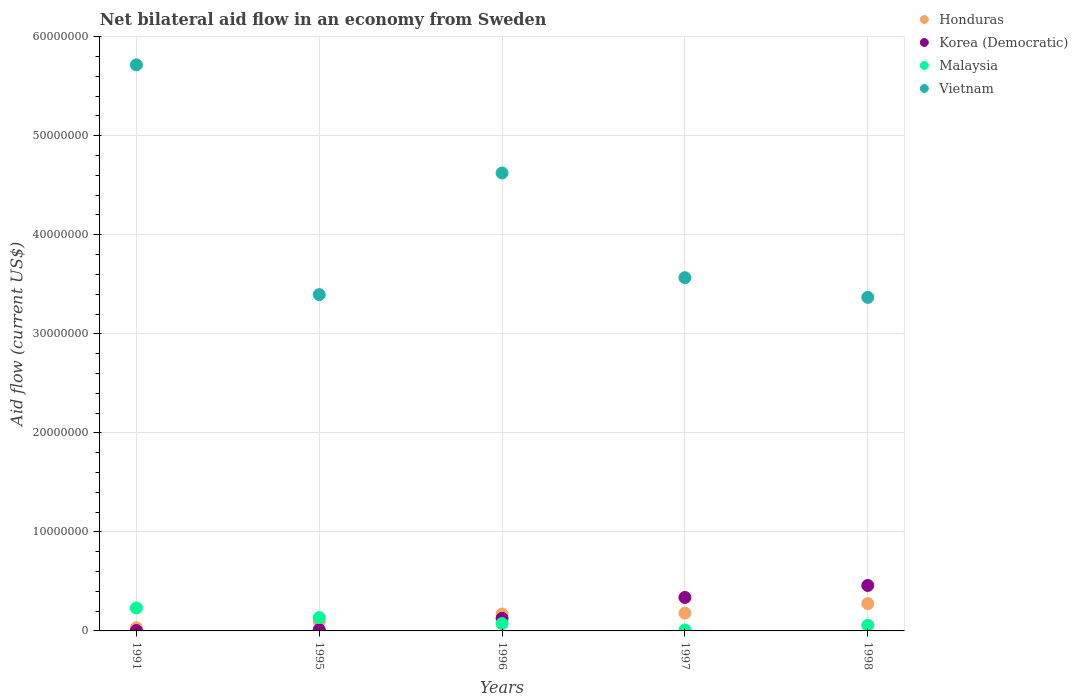What is the net bilateral aid flow in Malaysia in 1991?
Your response must be concise. 2.32e+06. Across all years, what is the maximum net bilateral aid flow in Korea (Democratic)?
Your answer should be compact. 4.59e+06. In which year was the net bilateral aid flow in Malaysia maximum?
Offer a terse response. 1991. In which year was the net bilateral aid flow in Malaysia minimum?
Provide a short and direct response. 1997. What is the total net bilateral aid flow in Korea (Democratic) in the graph?
Your response must be concise. 9.41e+06. What is the difference between the net bilateral aid flow in Korea (Democratic) in 1991 and that in 1997?
Keep it short and to the point. -3.34e+06. What is the difference between the net bilateral aid flow in Honduras in 1998 and the net bilateral aid flow in Malaysia in 1997?
Your answer should be very brief. 2.66e+06. What is the average net bilateral aid flow in Malaysia per year?
Make the answer very short. 1.02e+06. In the year 1997, what is the difference between the net bilateral aid flow in Korea (Democratic) and net bilateral aid flow in Malaysia?
Ensure brevity in your answer.  3.28e+06. In how many years, is the net bilateral aid flow in Honduras greater than 20000000 US$?
Provide a short and direct response. 0. What is the ratio of the net bilateral aid flow in Vietnam in 1991 to that in 1997?
Give a very brief answer. 1.6. Is the net bilateral aid flow in Vietnam in 1997 less than that in 1998?
Offer a very short reply. No. Is the difference between the net bilateral aid flow in Korea (Democratic) in 1991 and 1997 greater than the difference between the net bilateral aid flow in Malaysia in 1991 and 1997?
Provide a succinct answer. No. What is the difference between the highest and the second highest net bilateral aid flow in Vietnam?
Your response must be concise. 1.09e+07. What is the difference between the highest and the lowest net bilateral aid flow in Malaysia?
Your answer should be compact. 2.22e+06. In how many years, is the net bilateral aid flow in Vietnam greater than the average net bilateral aid flow in Vietnam taken over all years?
Keep it short and to the point. 2. Is the sum of the net bilateral aid flow in Honduras in 1995 and 1997 greater than the maximum net bilateral aid flow in Korea (Democratic) across all years?
Offer a very short reply. No. Is it the case that in every year, the sum of the net bilateral aid flow in Honduras and net bilateral aid flow in Korea (Democratic)  is greater than the sum of net bilateral aid flow in Malaysia and net bilateral aid flow in Vietnam?
Give a very brief answer. No. Is the net bilateral aid flow in Vietnam strictly greater than the net bilateral aid flow in Honduras over the years?
Give a very brief answer. Yes. How many years are there in the graph?
Your answer should be very brief. 5. Does the graph contain any zero values?
Keep it short and to the point. No. Where does the legend appear in the graph?
Your answer should be very brief. Top right. How many legend labels are there?
Offer a very short reply. 4. What is the title of the graph?
Give a very brief answer. Net bilateral aid flow in an economy from Sweden. What is the label or title of the Y-axis?
Your answer should be compact. Aid flow (current US$). What is the Aid flow (current US$) of Malaysia in 1991?
Provide a succinct answer. 2.32e+06. What is the Aid flow (current US$) in Vietnam in 1991?
Ensure brevity in your answer.  5.72e+07. What is the Aid flow (current US$) in Honduras in 1995?
Provide a short and direct response. 9.50e+05. What is the Aid flow (current US$) in Korea (Democratic) in 1995?
Provide a short and direct response. 1.30e+05. What is the Aid flow (current US$) of Malaysia in 1995?
Offer a very short reply. 1.35e+06. What is the Aid flow (current US$) of Vietnam in 1995?
Give a very brief answer. 3.40e+07. What is the Aid flow (current US$) of Honduras in 1996?
Your answer should be very brief. 1.71e+06. What is the Aid flow (current US$) of Korea (Democratic) in 1996?
Ensure brevity in your answer.  1.27e+06. What is the Aid flow (current US$) in Malaysia in 1996?
Offer a very short reply. 7.40e+05. What is the Aid flow (current US$) of Vietnam in 1996?
Provide a short and direct response. 4.62e+07. What is the Aid flow (current US$) in Honduras in 1997?
Offer a very short reply. 1.80e+06. What is the Aid flow (current US$) of Korea (Democratic) in 1997?
Provide a short and direct response. 3.38e+06. What is the Aid flow (current US$) of Vietnam in 1997?
Give a very brief answer. 3.57e+07. What is the Aid flow (current US$) in Honduras in 1998?
Give a very brief answer. 2.76e+06. What is the Aid flow (current US$) of Korea (Democratic) in 1998?
Make the answer very short. 4.59e+06. What is the Aid flow (current US$) in Malaysia in 1998?
Offer a terse response. 5.70e+05. What is the Aid flow (current US$) in Vietnam in 1998?
Offer a very short reply. 3.37e+07. Across all years, what is the maximum Aid flow (current US$) in Honduras?
Provide a succinct answer. 2.76e+06. Across all years, what is the maximum Aid flow (current US$) in Korea (Democratic)?
Provide a short and direct response. 4.59e+06. Across all years, what is the maximum Aid flow (current US$) of Malaysia?
Offer a very short reply. 2.32e+06. Across all years, what is the maximum Aid flow (current US$) of Vietnam?
Give a very brief answer. 5.72e+07. Across all years, what is the minimum Aid flow (current US$) in Vietnam?
Offer a terse response. 3.37e+07. What is the total Aid flow (current US$) of Honduras in the graph?
Offer a terse response. 7.53e+06. What is the total Aid flow (current US$) of Korea (Democratic) in the graph?
Provide a succinct answer. 9.41e+06. What is the total Aid flow (current US$) in Malaysia in the graph?
Make the answer very short. 5.08e+06. What is the total Aid flow (current US$) of Vietnam in the graph?
Make the answer very short. 2.07e+08. What is the difference between the Aid flow (current US$) of Honduras in 1991 and that in 1995?
Provide a succinct answer. -6.40e+05. What is the difference between the Aid flow (current US$) of Korea (Democratic) in 1991 and that in 1995?
Keep it short and to the point. -9.00e+04. What is the difference between the Aid flow (current US$) in Malaysia in 1991 and that in 1995?
Your answer should be very brief. 9.70e+05. What is the difference between the Aid flow (current US$) in Vietnam in 1991 and that in 1995?
Your answer should be very brief. 2.32e+07. What is the difference between the Aid flow (current US$) in Honduras in 1991 and that in 1996?
Offer a very short reply. -1.40e+06. What is the difference between the Aid flow (current US$) in Korea (Democratic) in 1991 and that in 1996?
Your answer should be very brief. -1.23e+06. What is the difference between the Aid flow (current US$) in Malaysia in 1991 and that in 1996?
Keep it short and to the point. 1.58e+06. What is the difference between the Aid flow (current US$) of Vietnam in 1991 and that in 1996?
Give a very brief answer. 1.09e+07. What is the difference between the Aid flow (current US$) of Honduras in 1991 and that in 1997?
Ensure brevity in your answer.  -1.49e+06. What is the difference between the Aid flow (current US$) of Korea (Democratic) in 1991 and that in 1997?
Offer a very short reply. -3.34e+06. What is the difference between the Aid flow (current US$) of Malaysia in 1991 and that in 1997?
Your answer should be very brief. 2.22e+06. What is the difference between the Aid flow (current US$) of Vietnam in 1991 and that in 1997?
Offer a very short reply. 2.15e+07. What is the difference between the Aid flow (current US$) in Honduras in 1991 and that in 1998?
Keep it short and to the point. -2.45e+06. What is the difference between the Aid flow (current US$) in Korea (Democratic) in 1991 and that in 1998?
Your response must be concise. -4.55e+06. What is the difference between the Aid flow (current US$) of Malaysia in 1991 and that in 1998?
Your answer should be compact. 1.75e+06. What is the difference between the Aid flow (current US$) in Vietnam in 1991 and that in 1998?
Offer a terse response. 2.35e+07. What is the difference between the Aid flow (current US$) in Honduras in 1995 and that in 1996?
Provide a short and direct response. -7.60e+05. What is the difference between the Aid flow (current US$) of Korea (Democratic) in 1995 and that in 1996?
Your answer should be compact. -1.14e+06. What is the difference between the Aid flow (current US$) of Vietnam in 1995 and that in 1996?
Your response must be concise. -1.23e+07. What is the difference between the Aid flow (current US$) in Honduras in 1995 and that in 1997?
Give a very brief answer. -8.50e+05. What is the difference between the Aid flow (current US$) in Korea (Democratic) in 1995 and that in 1997?
Provide a short and direct response. -3.25e+06. What is the difference between the Aid flow (current US$) in Malaysia in 1995 and that in 1997?
Offer a very short reply. 1.25e+06. What is the difference between the Aid flow (current US$) in Vietnam in 1995 and that in 1997?
Provide a succinct answer. -1.71e+06. What is the difference between the Aid flow (current US$) of Honduras in 1995 and that in 1998?
Ensure brevity in your answer.  -1.81e+06. What is the difference between the Aid flow (current US$) in Korea (Democratic) in 1995 and that in 1998?
Provide a short and direct response. -4.46e+06. What is the difference between the Aid flow (current US$) of Malaysia in 1995 and that in 1998?
Offer a very short reply. 7.80e+05. What is the difference between the Aid flow (current US$) in Honduras in 1996 and that in 1997?
Your answer should be very brief. -9.00e+04. What is the difference between the Aid flow (current US$) of Korea (Democratic) in 1996 and that in 1997?
Your answer should be compact. -2.11e+06. What is the difference between the Aid flow (current US$) of Malaysia in 1996 and that in 1997?
Provide a succinct answer. 6.40e+05. What is the difference between the Aid flow (current US$) in Vietnam in 1996 and that in 1997?
Your answer should be very brief. 1.06e+07. What is the difference between the Aid flow (current US$) of Honduras in 1996 and that in 1998?
Provide a short and direct response. -1.05e+06. What is the difference between the Aid flow (current US$) of Korea (Democratic) in 1996 and that in 1998?
Your answer should be very brief. -3.32e+06. What is the difference between the Aid flow (current US$) of Vietnam in 1996 and that in 1998?
Make the answer very short. 1.26e+07. What is the difference between the Aid flow (current US$) in Honduras in 1997 and that in 1998?
Your answer should be very brief. -9.60e+05. What is the difference between the Aid flow (current US$) in Korea (Democratic) in 1997 and that in 1998?
Offer a terse response. -1.21e+06. What is the difference between the Aid flow (current US$) in Malaysia in 1997 and that in 1998?
Offer a very short reply. -4.70e+05. What is the difference between the Aid flow (current US$) of Vietnam in 1997 and that in 1998?
Make the answer very short. 1.99e+06. What is the difference between the Aid flow (current US$) of Honduras in 1991 and the Aid flow (current US$) of Malaysia in 1995?
Give a very brief answer. -1.04e+06. What is the difference between the Aid flow (current US$) of Honduras in 1991 and the Aid flow (current US$) of Vietnam in 1995?
Your answer should be very brief. -3.36e+07. What is the difference between the Aid flow (current US$) of Korea (Democratic) in 1991 and the Aid flow (current US$) of Malaysia in 1995?
Your response must be concise. -1.31e+06. What is the difference between the Aid flow (current US$) in Korea (Democratic) in 1991 and the Aid flow (current US$) in Vietnam in 1995?
Your answer should be compact. -3.39e+07. What is the difference between the Aid flow (current US$) in Malaysia in 1991 and the Aid flow (current US$) in Vietnam in 1995?
Make the answer very short. -3.16e+07. What is the difference between the Aid flow (current US$) in Honduras in 1991 and the Aid flow (current US$) in Korea (Democratic) in 1996?
Your answer should be very brief. -9.60e+05. What is the difference between the Aid flow (current US$) of Honduras in 1991 and the Aid flow (current US$) of Malaysia in 1996?
Offer a very short reply. -4.30e+05. What is the difference between the Aid flow (current US$) of Honduras in 1991 and the Aid flow (current US$) of Vietnam in 1996?
Your answer should be compact. -4.59e+07. What is the difference between the Aid flow (current US$) of Korea (Democratic) in 1991 and the Aid flow (current US$) of Malaysia in 1996?
Ensure brevity in your answer.  -7.00e+05. What is the difference between the Aid flow (current US$) in Korea (Democratic) in 1991 and the Aid flow (current US$) in Vietnam in 1996?
Give a very brief answer. -4.62e+07. What is the difference between the Aid flow (current US$) of Malaysia in 1991 and the Aid flow (current US$) of Vietnam in 1996?
Make the answer very short. -4.39e+07. What is the difference between the Aid flow (current US$) in Honduras in 1991 and the Aid flow (current US$) in Korea (Democratic) in 1997?
Your response must be concise. -3.07e+06. What is the difference between the Aid flow (current US$) in Honduras in 1991 and the Aid flow (current US$) in Malaysia in 1997?
Make the answer very short. 2.10e+05. What is the difference between the Aid flow (current US$) of Honduras in 1991 and the Aid flow (current US$) of Vietnam in 1997?
Your response must be concise. -3.54e+07. What is the difference between the Aid flow (current US$) of Korea (Democratic) in 1991 and the Aid flow (current US$) of Vietnam in 1997?
Offer a very short reply. -3.56e+07. What is the difference between the Aid flow (current US$) of Malaysia in 1991 and the Aid flow (current US$) of Vietnam in 1997?
Provide a short and direct response. -3.34e+07. What is the difference between the Aid flow (current US$) in Honduras in 1991 and the Aid flow (current US$) in Korea (Democratic) in 1998?
Keep it short and to the point. -4.28e+06. What is the difference between the Aid flow (current US$) of Honduras in 1991 and the Aid flow (current US$) of Malaysia in 1998?
Provide a succinct answer. -2.60e+05. What is the difference between the Aid flow (current US$) of Honduras in 1991 and the Aid flow (current US$) of Vietnam in 1998?
Your answer should be very brief. -3.34e+07. What is the difference between the Aid flow (current US$) in Korea (Democratic) in 1991 and the Aid flow (current US$) in Malaysia in 1998?
Make the answer very short. -5.30e+05. What is the difference between the Aid flow (current US$) in Korea (Democratic) in 1991 and the Aid flow (current US$) in Vietnam in 1998?
Your response must be concise. -3.36e+07. What is the difference between the Aid flow (current US$) of Malaysia in 1991 and the Aid flow (current US$) of Vietnam in 1998?
Your response must be concise. -3.14e+07. What is the difference between the Aid flow (current US$) in Honduras in 1995 and the Aid flow (current US$) in Korea (Democratic) in 1996?
Give a very brief answer. -3.20e+05. What is the difference between the Aid flow (current US$) of Honduras in 1995 and the Aid flow (current US$) of Vietnam in 1996?
Your response must be concise. -4.53e+07. What is the difference between the Aid flow (current US$) of Korea (Democratic) in 1995 and the Aid flow (current US$) of Malaysia in 1996?
Ensure brevity in your answer.  -6.10e+05. What is the difference between the Aid flow (current US$) of Korea (Democratic) in 1995 and the Aid flow (current US$) of Vietnam in 1996?
Make the answer very short. -4.61e+07. What is the difference between the Aid flow (current US$) of Malaysia in 1995 and the Aid flow (current US$) of Vietnam in 1996?
Give a very brief answer. -4.49e+07. What is the difference between the Aid flow (current US$) of Honduras in 1995 and the Aid flow (current US$) of Korea (Democratic) in 1997?
Offer a very short reply. -2.43e+06. What is the difference between the Aid flow (current US$) in Honduras in 1995 and the Aid flow (current US$) in Malaysia in 1997?
Make the answer very short. 8.50e+05. What is the difference between the Aid flow (current US$) of Honduras in 1995 and the Aid flow (current US$) of Vietnam in 1997?
Offer a terse response. -3.47e+07. What is the difference between the Aid flow (current US$) of Korea (Democratic) in 1995 and the Aid flow (current US$) of Malaysia in 1997?
Provide a succinct answer. 3.00e+04. What is the difference between the Aid flow (current US$) of Korea (Democratic) in 1995 and the Aid flow (current US$) of Vietnam in 1997?
Provide a succinct answer. -3.55e+07. What is the difference between the Aid flow (current US$) in Malaysia in 1995 and the Aid flow (current US$) in Vietnam in 1997?
Provide a succinct answer. -3.43e+07. What is the difference between the Aid flow (current US$) of Honduras in 1995 and the Aid flow (current US$) of Korea (Democratic) in 1998?
Provide a succinct answer. -3.64e+06. What is the difference between the Aid flow (current US$) in Honduras in 1995 and the Aid flow (current US$) in Vietnam in 1998?
Offer a very short reply. -3.27e+07. What is the difference between the Aid flow (current US$) of Korea (Democratic) in 1995 and the Aid flow (current US$) of Malaysia in 1998?
Your response must be concise. -4.40e+05. What is the difference between the Aid flow (current US$) of Korea (Democratic) in 1995 and the Aid flow (current US$) of Vietnam in 1998?
Offer a very short reply. -3.36e+07. What is the difference between the Aid flow (current US$) in Malaysia in 1995 and the Aid flow (current US$) in Vietnam in 1998?
Provide a short and direct response. -3.23e+07. What is the difference between the Aid flow (current US$) in Honduras in 1996 and the Aid flow (current US$) in Korea (Democratic) in 1997?
Your answer should be compact. -1.67e+06. What is the difference between the Aid flow (current US$) in Honduras in 1996 and the Aid flow (current US$) in Malaysia in 1997?
Ensure brevity in your answer.  1.61e+06. What is the difference between the Aid flow (current US$) in Honduras in 1996 and the Aid flow (current US$) in Vietnam in 1997?
Provide a short and direct response. -3.40e+07. What is the difference between the Aid flow (current US$) in Korea (Democratic) in 1996 and the Aid flow (current US$) in Malaysia in 1997?
Provide a succinct answer. 1.17e+06. What is the difference between the Aid flow (current US$) in Korea (Democratic) in 1996 and the Aid flow (current US$) in Vietnam in 1997?
Your response must be concise. -3.44e+07. What is the difference between the Aid flow (current US$) of Malaysia in 1996 and the Aid flow (current US$) of Vietnam in 1997?
Offer a terse response. -3.49e+07. What is the difference between the Aid flow (current US$) in Honduras in 1996 and the Aid flow (current US$) in Korea (Democratic) in 1998?
Give a very brief answer. -2.88e+06. What is the difference between the Aid flow (current US$) in Honduras in 1996 and the Aid flow (current US$) in Malaysia in 1998?
Your answer should be very brief. 1.14e+06. What is the difference between the Aid flow (current US$) of Honduras in 1996 and the Aid flow (current US$) of Vietnam in 1998?
Your answer should be compact. -3.20e+07. What is the difference between the Aid flow (current US$) of Korea (Democratic) in 1996 and the Aid flow (current US$) of Vietnam in 1998?
Give a very brief answer. -3.24e+07. What is the difference between the Aid flow (current US$) of Malaysia in 1996 and the Aid flow (current US$) of Vietnam in 1998?
Your answer should be compact. -3.29e+07. What is the difference between the Aid flow (current US$) of Honduras in 1997 and the Aid flow (current US$) of Korea (Democratic) in 1998?
Give a very brief answer. -2.79e+06. What is the difference between the Aid flow (current US$) in Honduras in 1997 and the Aid flow (current US$) in Malaysia in 1998?
Offer a very short reply. 1.23e+06. What is the difference between the Aid flow (current US$) in Honduras in 1997 and the Aid flow (current US$) in Vietnam in 1998?
Provide a short and direct response. -3.19e+07. What is the difference between the Aid flow (current US$) of Korea (Democratic) in 1997 and the Aid flow (current US$) of Malaysia in 1998?
Offer a terse response. 2.81e+06. What is the difference between the Aid flow (current US$) of Korea (Democratic) in 1997 and the Aid flow (current US$) of Vietnam in 1998?
Your response must be concise. -3.03e+07. What is the difference between the Aid flow (current US$) of Malaysia in 1997 and the Aid flow (current US$) of Vietnam in 1998?
Give a very brief answer. -3.36e+07. What is the average Aid flow (current US$) in Honduras per year?
Make the answer very short. 1.51e+06. What is the average Aid flow (current US$) in Korea (Democratic) per year?
Ensure brevity in your answer.  1.88e+06. What is the average Aid flow (current US$) of Malaysia per year?
Provide a succinct answer. 1.02e+06. What is the average Aid flow (current US$) of Vietnam per year?
Keep it short and to the point. 4.13e+07. In the year 1991, what is the difference between the Aid flow (current US$) of Honduras and Aid flow (current US$) of Malaysia?
Keep it short and to the point. -2.01e+06. In the year 1991, what is the difference between the Aid flow (current US$) of Honduras and Aid flow (current US$) of Vietnam?
Make the answer very short. -5.68e+07. In the year 1991, what is the difference between the Aid flow (current US$) of Korea (Democratic) and Aid flow (current US$) of Malaysia?
Make the answer very short. -2.28e+06. In the year 1991, what is the difference between the Aid flow (current US$) of Korea (Democratic) and Aid flow (current US$) of Vietnam?
Provide a succinct answer. -5.71e+07. In the year 1991, what is the difference between the Aid flow (current US$) in Malaysia and Aid flow (current US$) in Vietnam?
Your response must be concise. -5.48e+07. In the year 1995, what is the difference between the Aid flow (current US$) in Honduras and Aid flow (current US$) in Korea (Democratic)?
Give a very brief answer. 8.20e+05. In the year 1995, what is the difference between the Aid flow (current US$) in Honduras and Aid flow (current US$) in Malaysia?
Offer a terse response. -4.00e+05. In the year 1995, what is the difference between the Aid flow (current US$) of Honduras and Aid flow (current US$) of Vietnam?
Provide a short and direct response. -3.30e+07. In the year 1995, what is the difference between the Aid flow (current US$) of Korea (Democratic) and Aid flow (current US$) of Malaysia?
Provide a succinct answer. -1.22e+06. In the year 1995, what is the difference between the Aid flow (current US$) in Korea (Democratic) and Aid flow (current US$) in Vietnam?
Provide a short and direct response. -3.38e+07. In the year 1995, what is the difference between the Aid flow (current US$) of Malaysia and Aid flow (current US$) of Vietnam?
Offer a terse response. -3.26e+07. In the year 1996, what is the difference between the Aid flow (current US$) of Honduras and Aid flow (current US$) of Malaysia?
Provide a succinct answer. 9.70e+05. In the year 1996, what is the difference between the Aid flow (current US$) of Honduras and Aid flow (current US$) of Vietnam?
Provide a short and direct response. -4.45e+07. In the year 1996, what is the difference between the Aid flow (current US$) in Korea (Democratic) and Aid flow (current US$) in Malaysia?
Keep it short and to the point. 5.30e+05. In the year 1996, what is the difference between the Aid flow (current US$) of Korea (Democratic) and Aid flow (current US$) of Vietnam?
Provide a succinct answer. -4.50e+07. In the year 1996, what is the difference between the Aid flow (current US$) of Malaysia and Aid flow (current US$) of Vietnam?
Provide a short and direct response. -4.55e+07. In the year 1997, what is the difference between the Aid flow (current US$) of Honduras and Aid flow (current US$) of Korea (Democratic)?
Make the answer very short. -1.58e+06. In the year 1997, what is the difference between the Aid flow (current US$) in Honduras and Aid flow (current US$) in Malaysia?
Your answer should be compact. 1.70e+06. In the year 1997, what is the difference between the Aid flow (current US$) in Honduras and Aid flow (current US$) in Vietnam?
Make the answer very short. -3.39e+07. In the year 1997, what is the difference between the Aid flow (current US$) of Korea (Democratic) and Aid flow (current US$) of Malaysia?
Give a very brief answer. 3.28e+06. In the year 1997, what is the difference between the Aid flow (current US$) of Korea (Democratic) and Aid flow (current US$) of Vietnam?
Provide a succinct answer. -3.23e+07. In the year 1997, what is the difference between the Aid flow (current US$) in Malaysia and Aid flow (current US$) in Vietnam?
Offer a terse response. -3.56e+07. In the year 1998, what is the difference between the Aid flow (current US$) in Honduras and Aid flow (current US$) in Korea (Democratic)?
Offer a terse response. -1.83e+06. In the year 1998, what is the difference between the Aid flow (current US$) in Honduras and Aid flow (current US$) in Malaysia?
Your response must be concise. 2.19e+06. In the year 1998, what is the difference between the Aid flow (current US$) in Honduras and Aid flow (current US$) in Vietnam?
Your response must be concise. -3.09e+07. In the year 1998, what is the difference between the Aid flow (current US$) in Korea (Democratic) and Aid flow (current US$) in Malaysia?
Offer a very short reply. 4.02e+06. In the year 1998, what is the difference between the Aid flow (current US$) in Korea (Democratic) and Aid flow (current US$) in Vietnam?
Your answer should be very brief. -2.91e+07. In the year 1998, what is the difference between the Aid flow (current US$) in Malaysia and Aid flow (current US$) in Vietnam?
Provide a short and direct response. -3.31e+07. What is the ratio of the Aid flow (current US$) of Honduras in 1991 to that in 1995?
Offer a terse response. 0.33. What is the ratio of the Aid flow (current US$) in Korea (Democratic) in 1991 to that in 1995?
Offer a terse response. 0.31. What is the ratio of the Aid flow (current US$) in Malaysia in 1991 to that in 1995?
Provide a short and direct response. 1.72. What is the ratio of the Aid flow (current US$) of Vietnam in 1991 to that in 1995?
Keep it short and to the point. 1.68. What is the ratio of the Aid flow (current US$) in Honduras in 1991 to that in 1996?
Your answer should be very brief. 0.18. What is the ratio of the Aid flow (current US$) in Korea (Democratic) in 1991 to that in 1996?
Provide a succinct answer. 0.03. What is the ratio of the Aid flow (current US$) in Malaysia in 1991 to that in 1996?
Provide a short and direct response. 3.14. What is the ratio of the Aid flow (current US$) of Vietnam in 1991 to that in 1996?
Make the answer very short. 1.24. What is the ratio of the Aid flow (current US$) of Honduras in 1991 to that in 1997?
Offer a very short reply. 0.17. What is the ratio of the Aid flow (current US$) in Korea (Democratic) in 1991 to that in 1997?
Your response must be concise. 0.01. What is the ratio of the Aid flow (current US$) of Malaysia in 1991 to that in 1997?
Offer a very short reply. 23.2. What is the ratio of the Aid flow (current US$) of Vietnam in 1991 to that in 1997?
Give a very brief answer. 1.6. What is the ratio of the Aid flow (current US$) in Honduras in 1991 to that in 1998?
Ensure brevity in your answer.  0.11. What is the ratio of the Aid flow (current US$) in Korea (Democratic) in 1991 to that in 1998?
Provide a succinct answer. 0.01. What is the ratio of the Aid flow (current US$) in Malaysia in 1991 to that in 1998?
Offer a very short reply. 4.07. What is the ratio of the Aid flow (current US$) of Vietnam in 1991 to that in 1998?
Offer a terse response. 1.7. What is the ratio of the Aid flow (current US$) in Honduras in 1995 to that in 1996?
Provide a succinct answer. 0.56. What is the ratio of the Aid flow (current US$) in Korea (Democratic) in 1995 to that in 1996?
Your response must be concise. 0.1. What is the ratio of the Aid flow (current US$) in Malaysia in 1995 to that in 1996?
Offer a very short reply. 1.82. What is the ratio of the Aid flow (current US$) of Vietnam in 1995 to that in 1996?
Provide a succinct answer. 0.73. What is the ratio of the Aid flow (current US$) in Honduras in 1995 to that in 1997?
Make the answer very short. 0.53. What is the ratio of the Aid flow (current US$) of Korea (Democratic) in 1995 to that in 1997?
Provide a succinct answer. 0.04. What is the ratio of the Aid flow (current US$) in Malaysia in 1995 to that in 1997?
Ensure brevity in your answer.  13.5. What is the ratio of the Aid flow (current US$) in Vietnam in 1995 to that in 1997?
Your answer should be compact. 0.95. What is the ratio of the Aid flow (current US$) in Honduras in 1995 to that in 1998?
Your answer should be very brief. 0.34. What is the ratio of the Aid flow (current US$) of Korea (Democratic) in 1995 to that in 1998?
Give a very brief answer. 0.03. What is the ratio of the Aid flow (current US$) in Malaysia in 1995 to that in 1998?
Your answer should be compact. 2.37. What is the ratio of the Aid flow (current US$) in Vietnam in 1995 to that in 1998?
Provide a succinct answer. 1.01. What is the ratio of the Aid flow (current US$) in Honduras in 1996 to that in 1997?
Offer a very short reply. 0.95. What is the ratio of the Aid flow (current US$) of Korea (Democratic) in 1996 to that in 1997?
Give a very brief answer. 0.38. What is the ratio of the Aid flow (current US$) in Malaysia in 1996 to that in 1997?
Your answer should be very brief. 7.4. What is the ratio of the Aid flow (current US$) in Vietnam in 1996 to that in 1997?
Your answer should be very brief. 1.3. What is the ratio of the Aid flow (current US$) of Honduras in 1996 to that in 1998?
Your response must be concise. 0.62. What is the ratio of the Aid flow (current US$) of Korea (Democratic) in 1996 to that in 1998?
Your response must be concise. 0.28. What is the ratio of the Aid flow (current US$) in Malaysia in 1996 to that in 1998?
Offer a terse response. 1.3. What is the ratio of the Aid flow (current US$) of Vietnam in 1996 to that in 1998?
Provide a short and direct response. 1.37. What is the ratio of the Aid flow (current US$) of Honduras in 1997 to that in 1998?
Give a very brief answer. 0.65. What is the ratio of the Aid flow (current US$) in Korea (Democratic) in 1997 to that in 1998?
Provide a short and direct response. 0.74. What is the ratio of the Aid flow (current US$) in Malaysia in 1997 to that in 1998?
Give a very brief answer. 0.18. What is the ratio of the Aid flow (current US$) in Vietnam in 1997 to that in 1998?
Offer a terse response. 1.06. What is the difference between the highest and the second highest Aid flow (current US$) in Honduras?
Provide a short and direct response. 9.60e+05. What is the difference between the highest and the second highest Aid flow (current US$) of Korea (Democratic)?
Provide a short and direct response. 1.21e+06. What is the difference between the highest and the second highest Aid flow (current US$) of Malaysia?
Make the answer very short. 9.70e+05. What is the difference between the highest and the second highest Aid flow (current US$) of Vietnam?
Ensure brevity in your answer.  1.09e+07. What is the difference between the highest and the lowest Aid flow (current US$) of Honduras?
Provide a succinct answer. 2.45e+06. What is the difference between the highest and the lowest Aid flow (current US$) in Korea (Democratic)?
Provide a succinct answer. 4.55e+06. What is the difference between the highest and the lowest Aid flow (current US$) in Malaysia?
Ensure brevity in your answer.  2.22e+06. What is the difference between the highest and the lowest Aid flow (current US$) of Vietnam?
Your answer should be compact. 2.35e+07. 